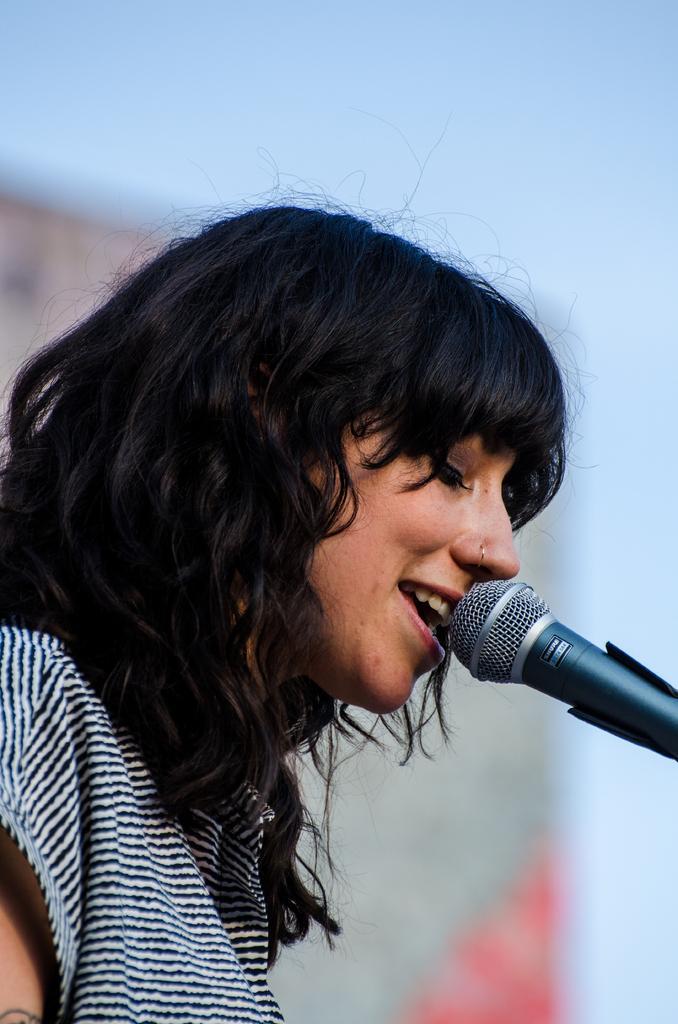How would you summarize this image in a sentence or two? In this picture there is a woman who is wearing a shirt. She is singing on the mic. On the top there is a sky. On the back we can see a banner. 